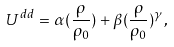Convert formula to latex. <formula><loc_0><loc_0><loc_500><loc_500>U ^ { d d } = \alpha ( \frac { \rho } { \rho _ { 0 } } ) + \beta ( \frac { \rho } { \rho _ { 0 } } ) ^ { \gamma } ,</formula> 